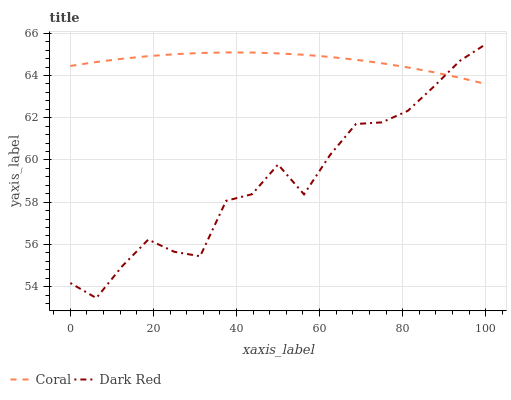Does Dark Red have the minimum area under the curve?
Answer yes or no. Yes. Does Coral have the maximum area under the curve?
Answer yes or no. Yes. Does Coral have the minimum area under the curve?
Answer yes or no. No. Is Coral the smoothest?
Answer yes or no. Yes. Is Dark Red the roughest?
Answer yes or no. Yes. Is Coral the roughest?
Answer yes or no. No. Does Dark Red have the lowest value?
Answer yes or no. Yes. Does Coral have the lowest value?
Answer yes or no. No. Does Dark Red have the highest value?
Answer yes or no. Yes. Does Coral have the highest value?
Answer yes or no. No. Does Coral intersect Dark Red?
Answer yes or no. Yes. Is Coral less than Dark Red?
Answer yes or no. No. Is Coral greater than Dark Red?
Answer yes or no. No. 